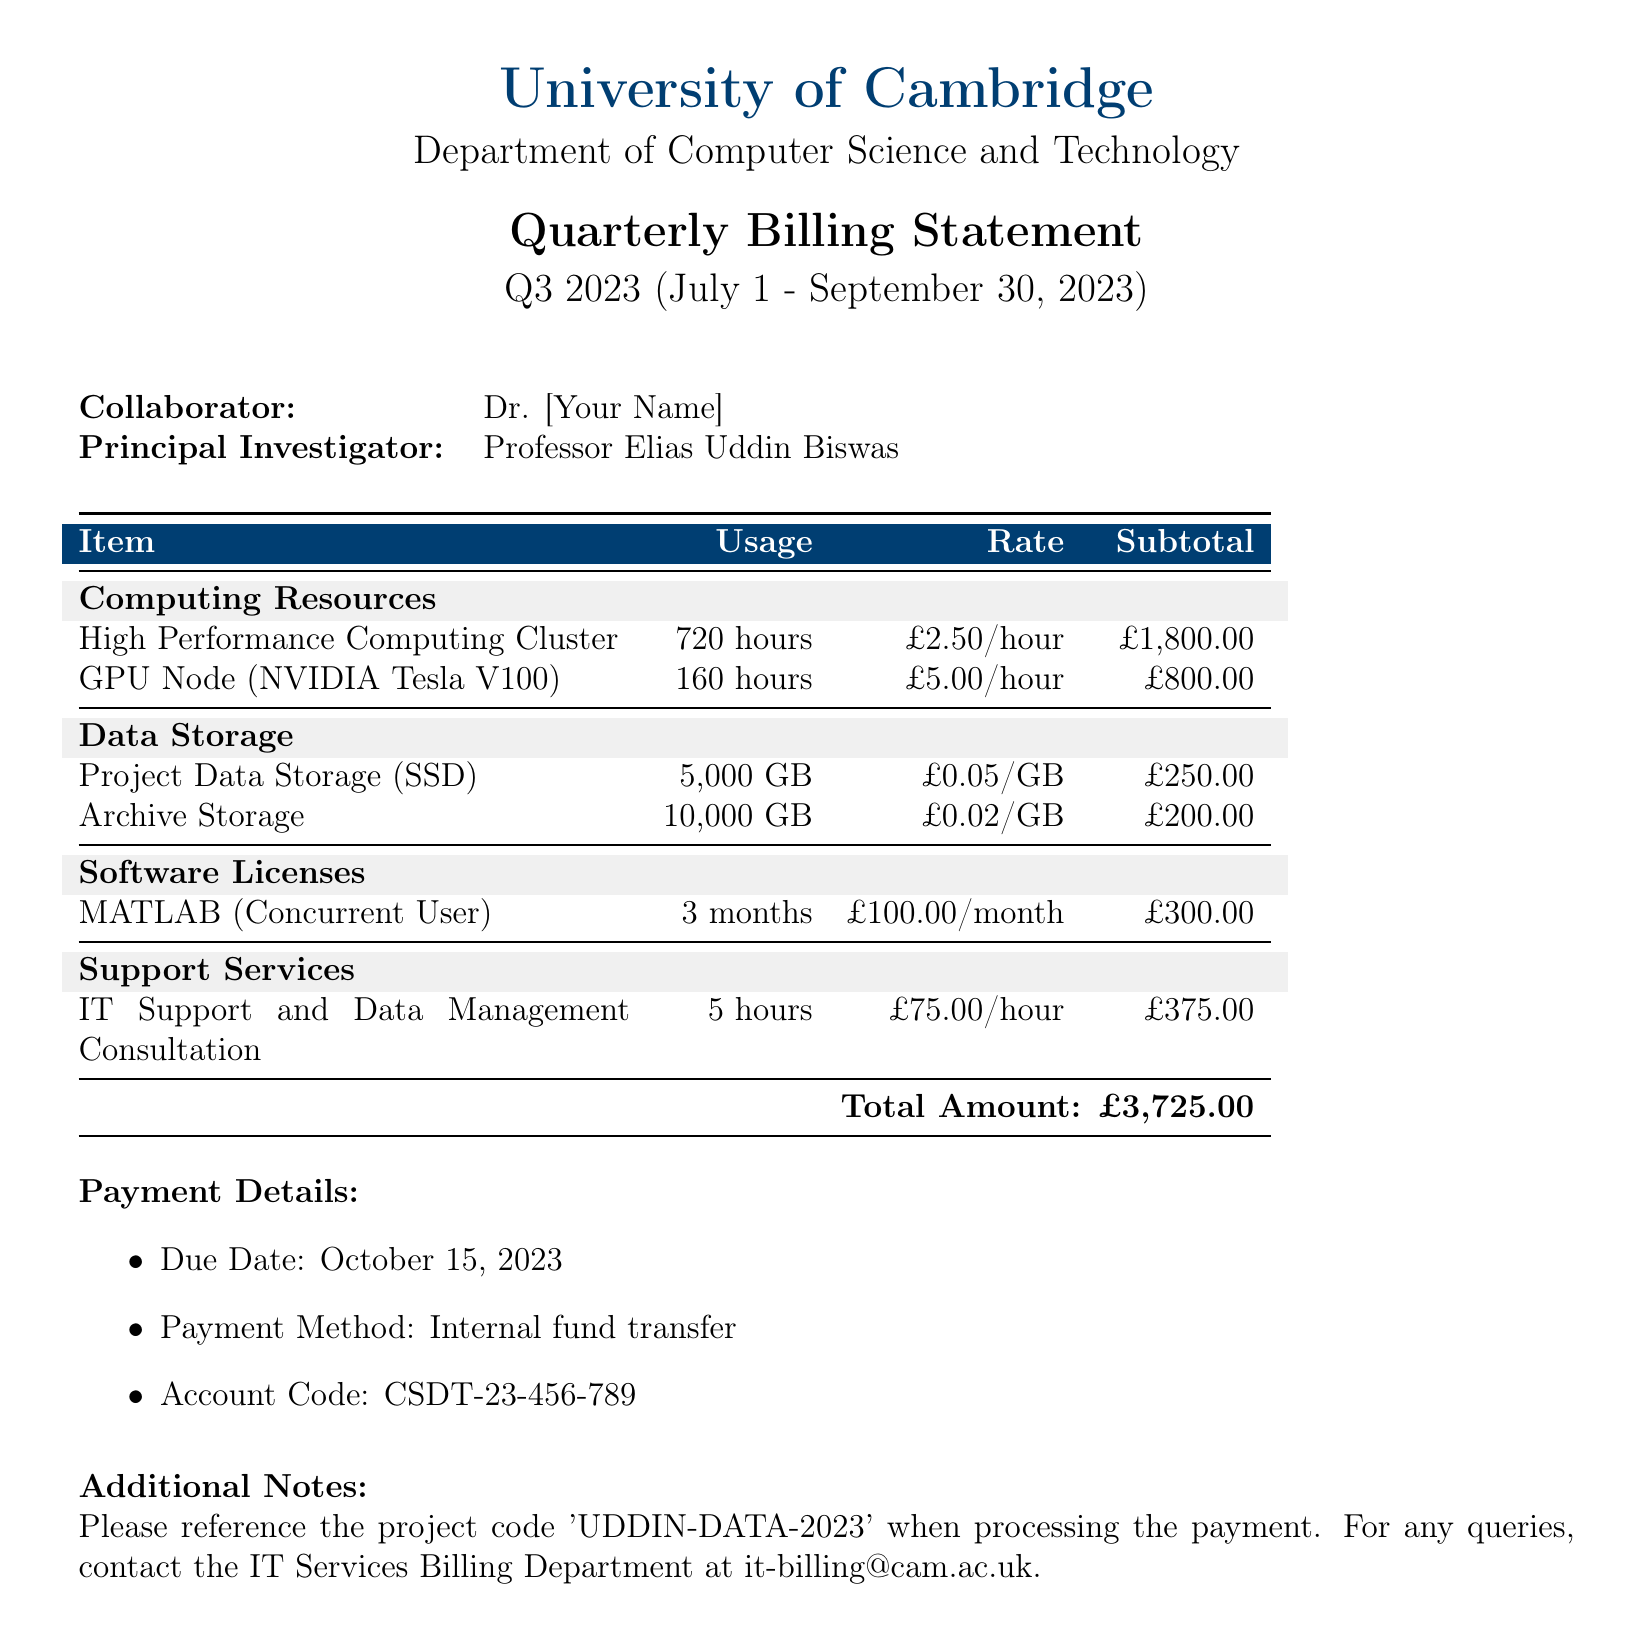What is the total amount due? The total amount due is specified in the final table of the document and is the sum of all subtotals.
Answer: £3,725.00 Who is the Principal Investigator? The document lists the Principal Investigator in the collaborator section, under Dr. [Your Name].
Answer: Professor Elias Uddin Biswas What is the due date for payment? The due date is specifically mentioned in the payment details section of the document.
Answer: October 15, 2023 How many hours of IT support consultation were billed? The hours billed for IT support and data management consultation are specified in the support services section.
Answer: 5 hours What is the rate for using a GPU Node? The rate for the GPU Node is provided in the computing resources section of the document.
Answer: £5.00/hour What project code should be referenced for payment? The project code to be referenced is mentioned in the additional notes section at the end of the document.
Answer: UDDIN-DATA-2023 How much was charged for project data storage? The subtotal for project data storage is detailed in the data storage section of the document.
Answer: £250.00 What type of software license is included in the bill? The software license specifically mentioned in the document is included under the software licenses section.
Answer: MATLAB (Concurrent User) How many months of MATLAB license were billed? The duration of the MATLAB license is stated in the software licenses section of the document.
Answer: 3 months 